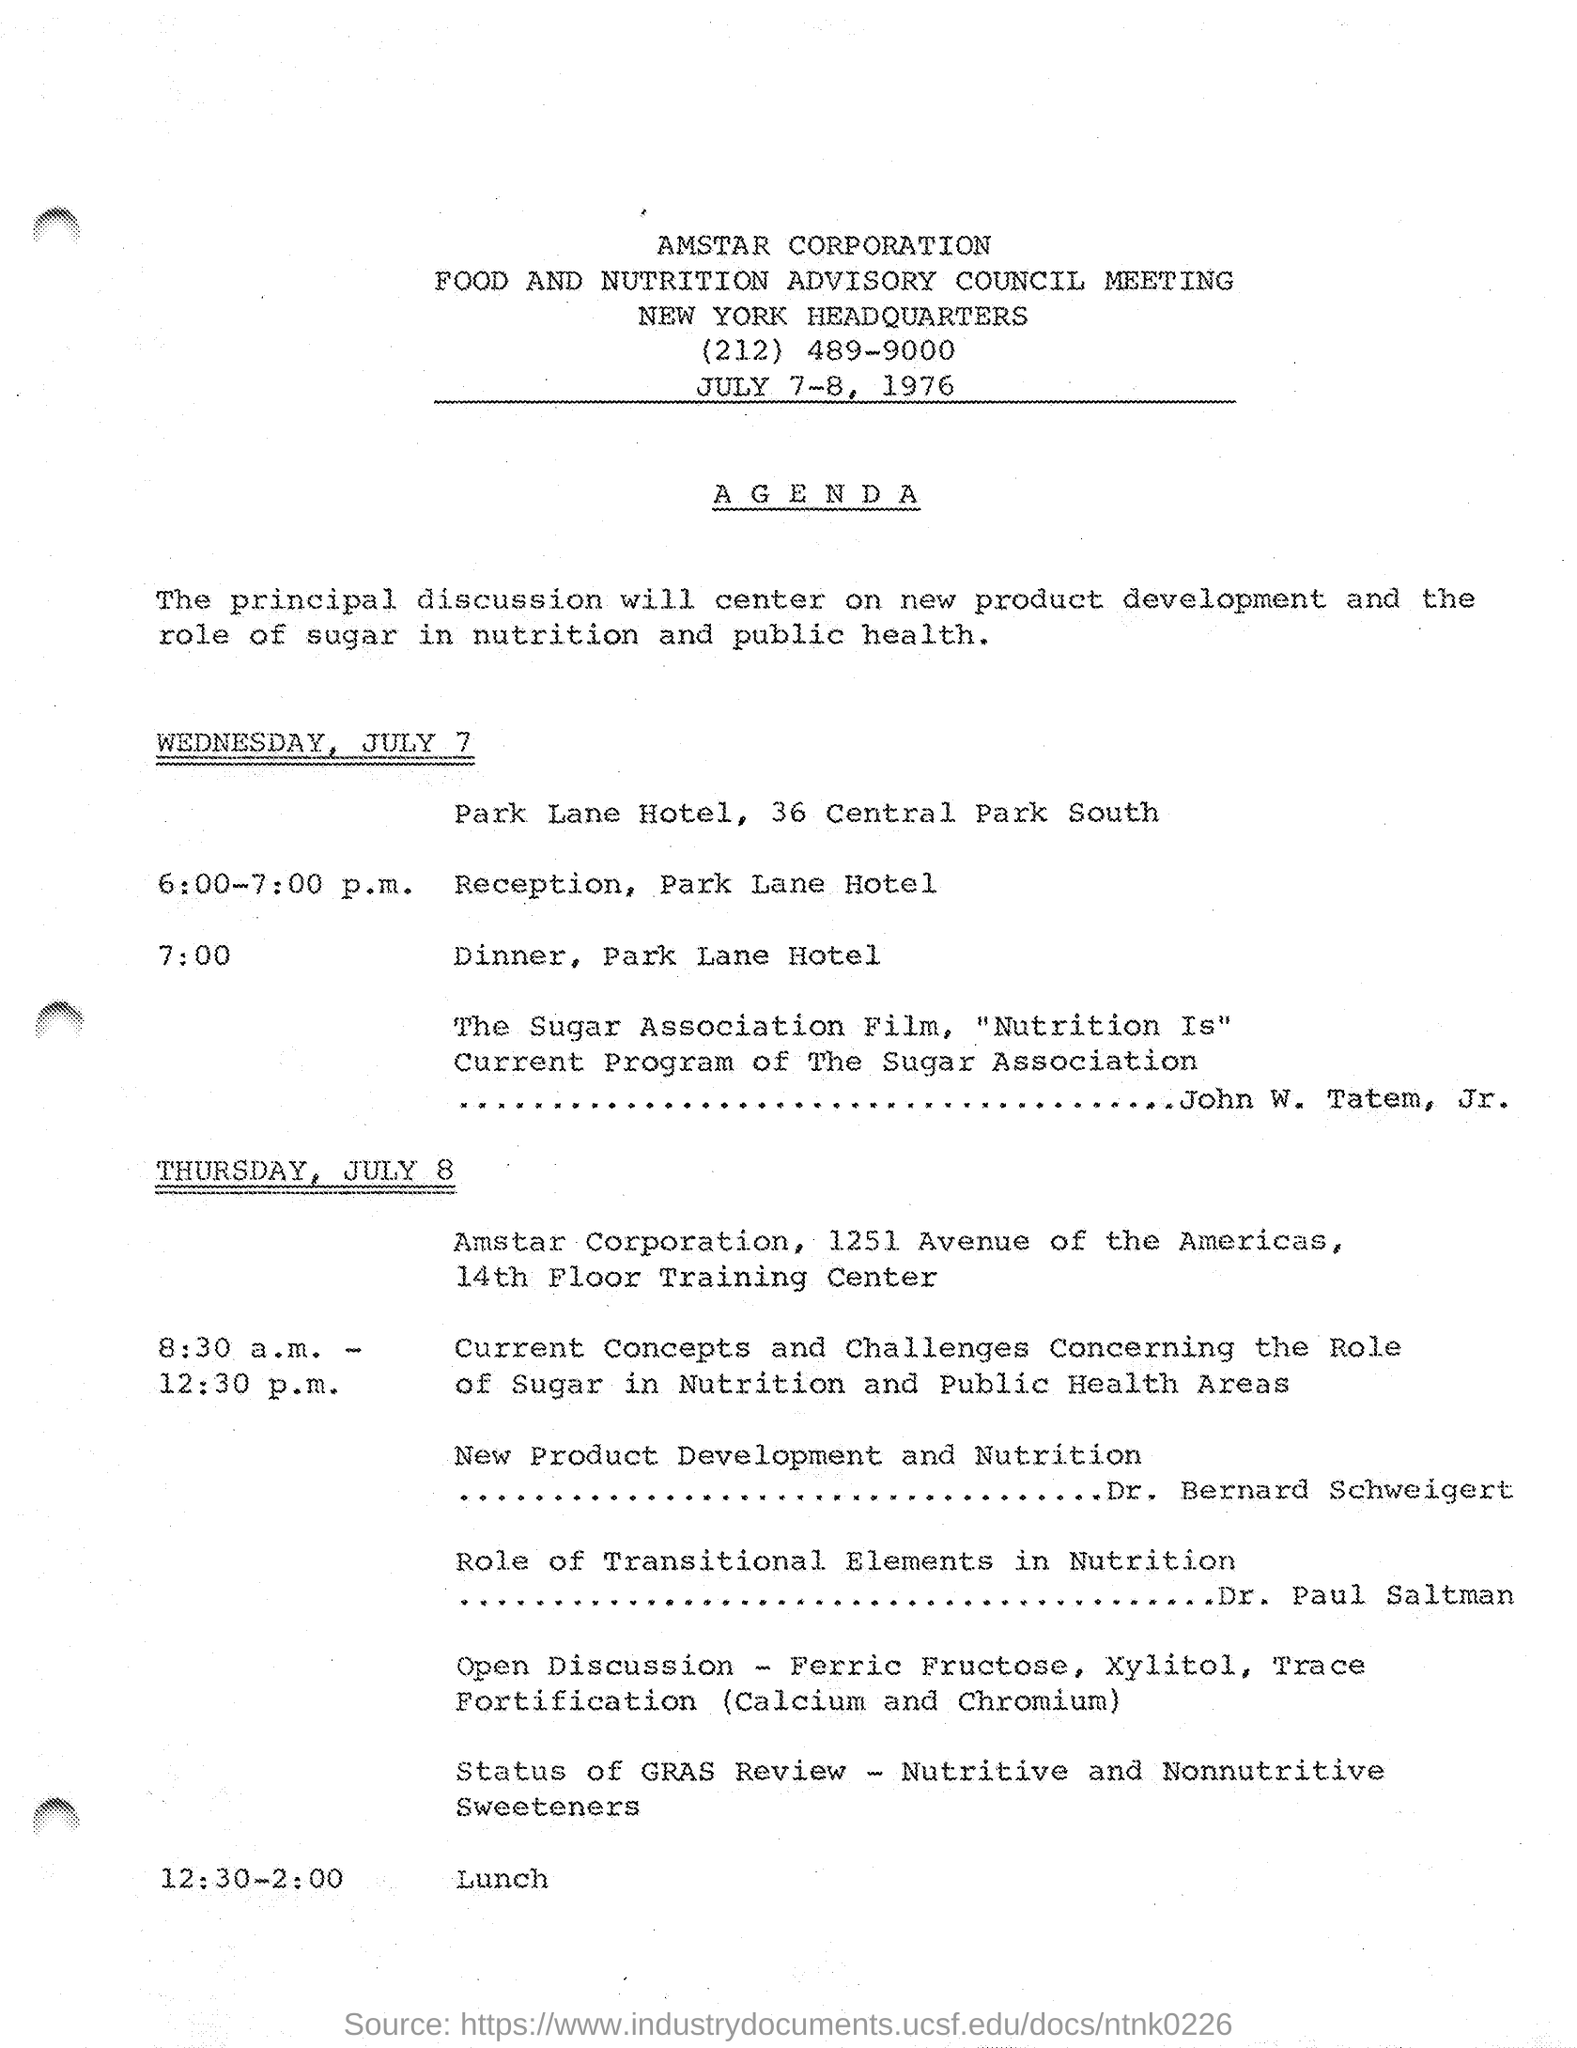What is the name of the corporation mentioned in the given page ?
Your response must be concise. Amstar corporation. Where is the head quarters located as mentioned in the given page ?
Offer a terse response. New York. What are the dates scheduled for the meeting as mentioned in the given page ?
Your answer should be compact. JULY 7-8, 1976. What is the program at 6:00 - 7:00 pm on wednesday , july 7?
Offer a very short reply. Reception , park lane hotel. What is the given schedule at the time of 7:00 ?
Your response must be concise. Dinner, Park Lane Hotel. What is the given schedule at the time of 8:30 a.m-12:30 p.m on thursday , july 8 ?
Make the answer very short. Current Concepts and Challenges Concerning the Role of Sugar in Nutrition and Public Health Areas. What is the given schedule at the time of 12:30 - 2:00 on july 8 ?
Ensure brevity in your answer.  Lunch. 